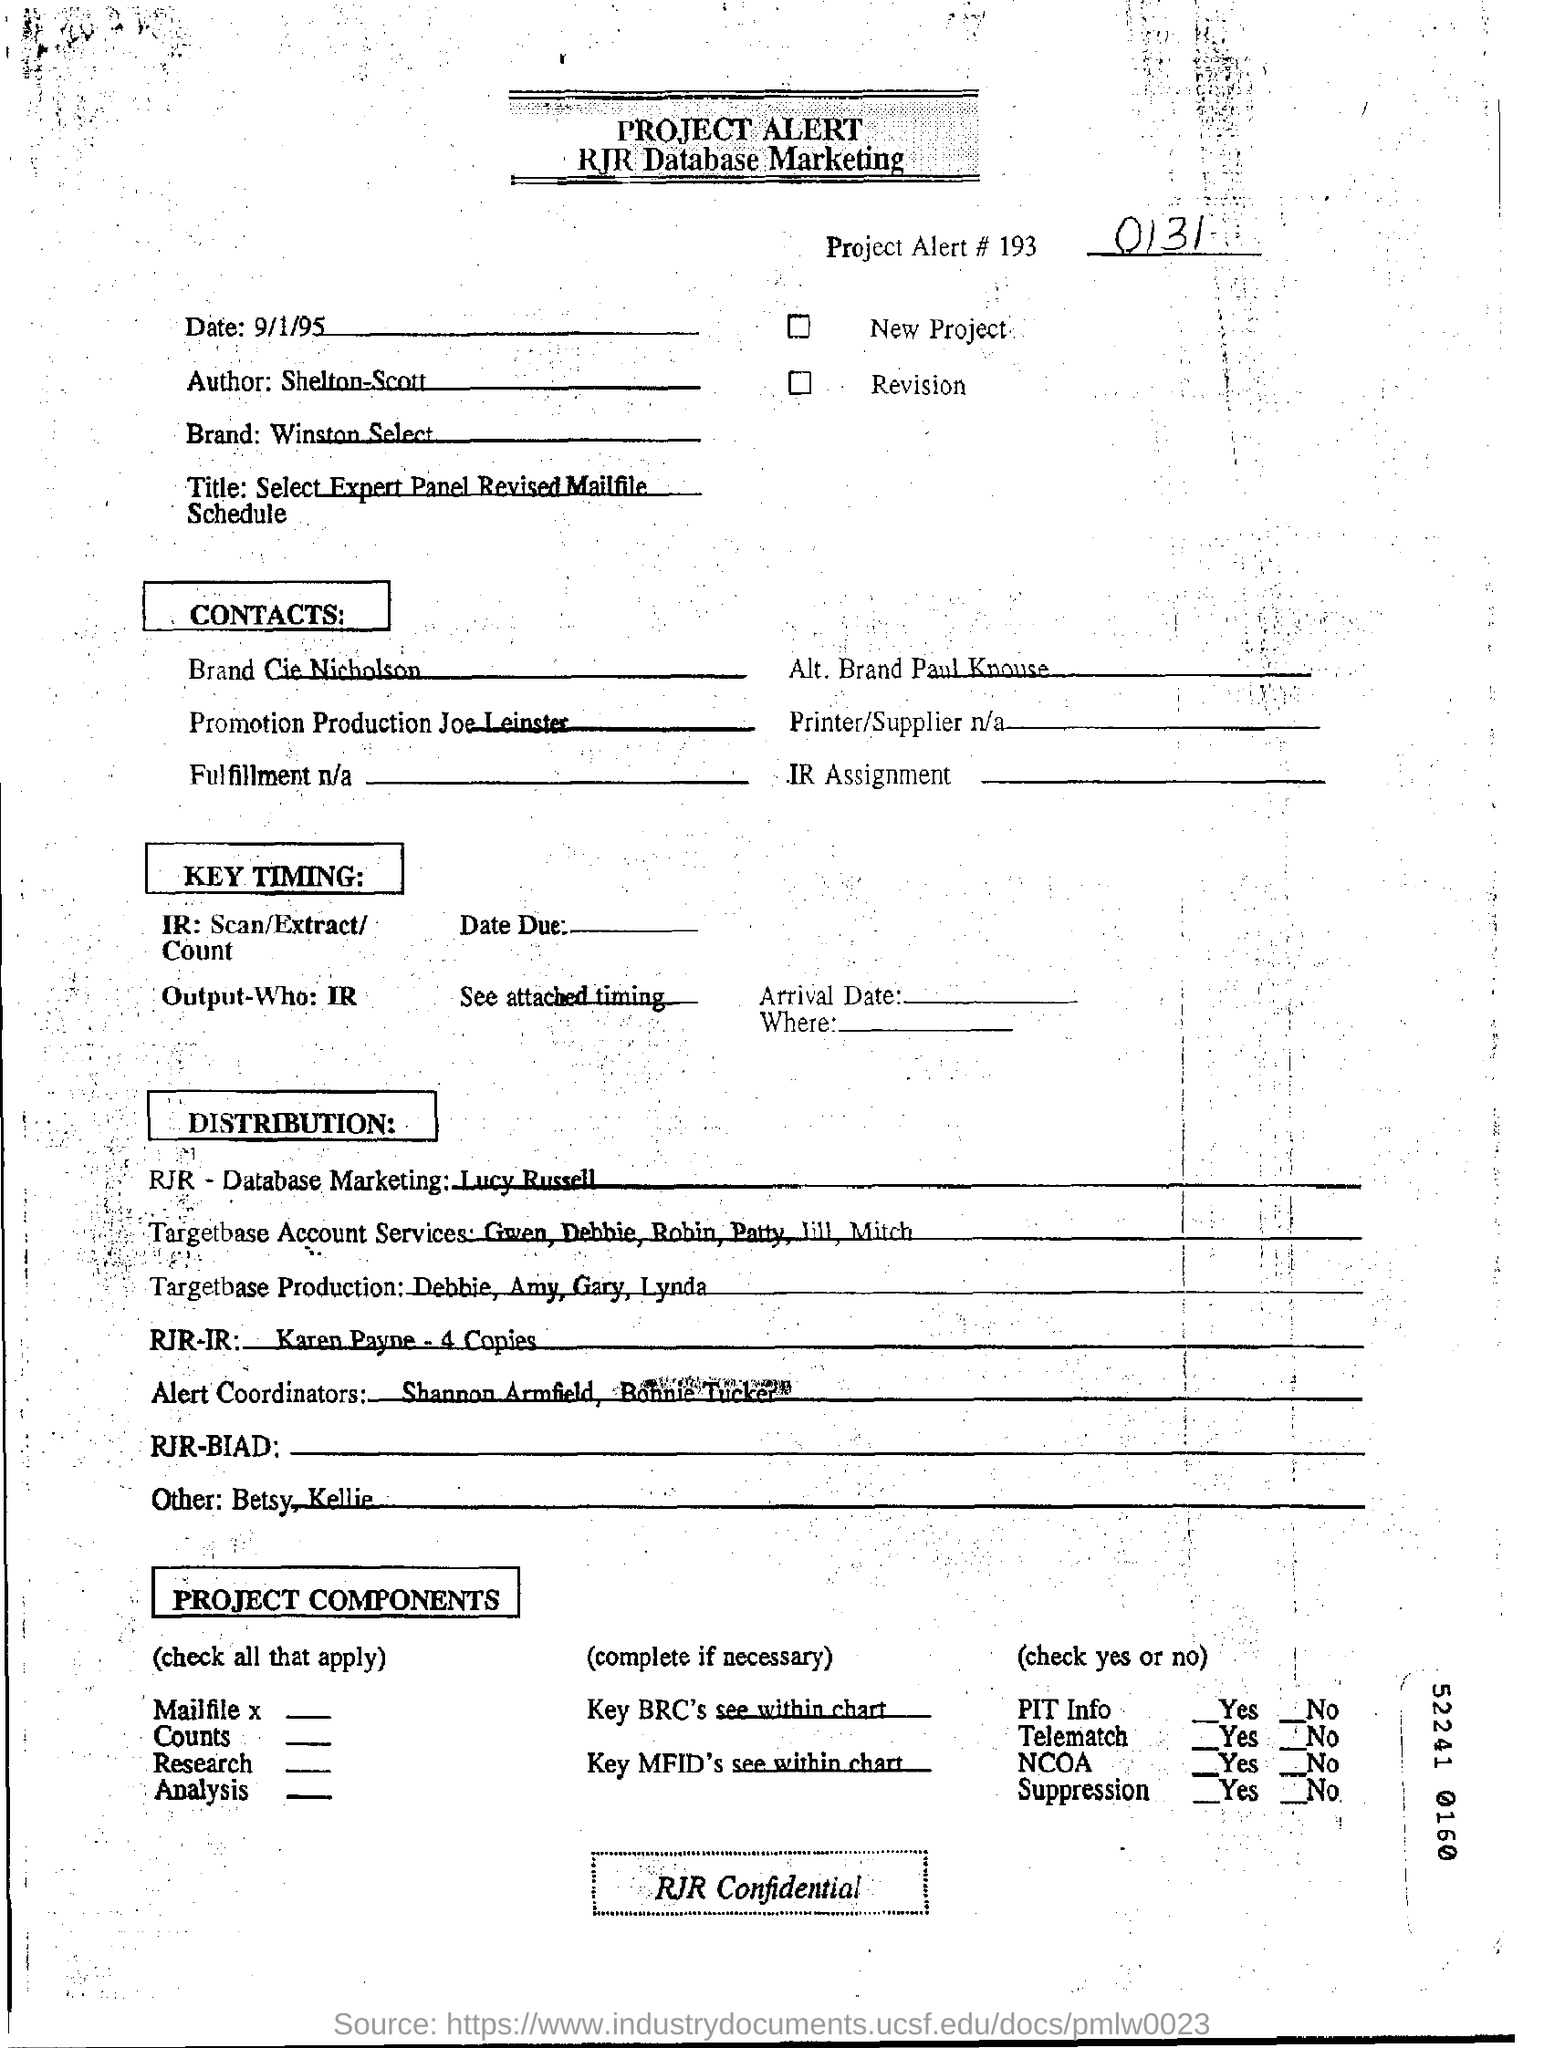What is the number of the project alert#193?
Your answer should be very brief. 0131. What is the name of the author?
Provide a succinct answer. Shelton-scott. What is the name of the brand ?
Your answer should be very brief. Winston select. What is the date in the rjr database marketing ?
Ensure brevity in your answer.  9/1/95. 